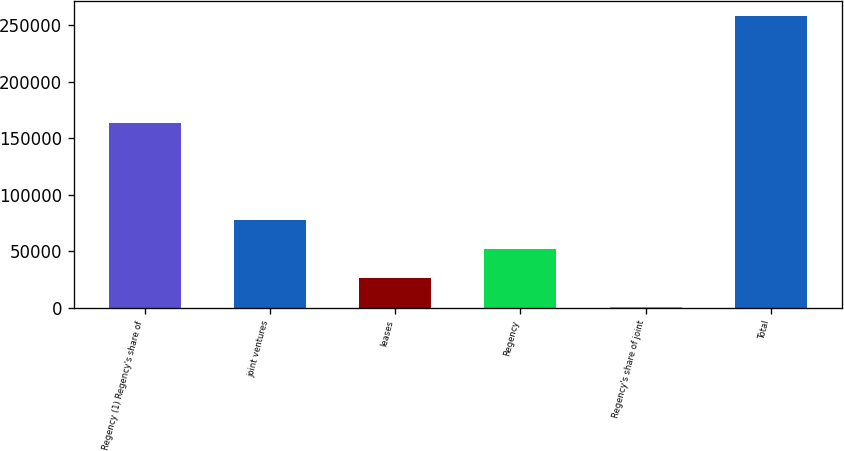Convert chart to OTSL. <chart><loc_0><loc_0><loc_500><loc_500><bar_chart><fcel>Regency (1) Regency's share of<fcel>joint ventures<fcel>leases<fcel>Regency<fcel>Regency's share of joint<fcel>Total<nl><fcel>163223<fcel>77685.3<fcel>26157.1<fcel>51921.2<fcel>393<fcel>258034<nl></chart> 